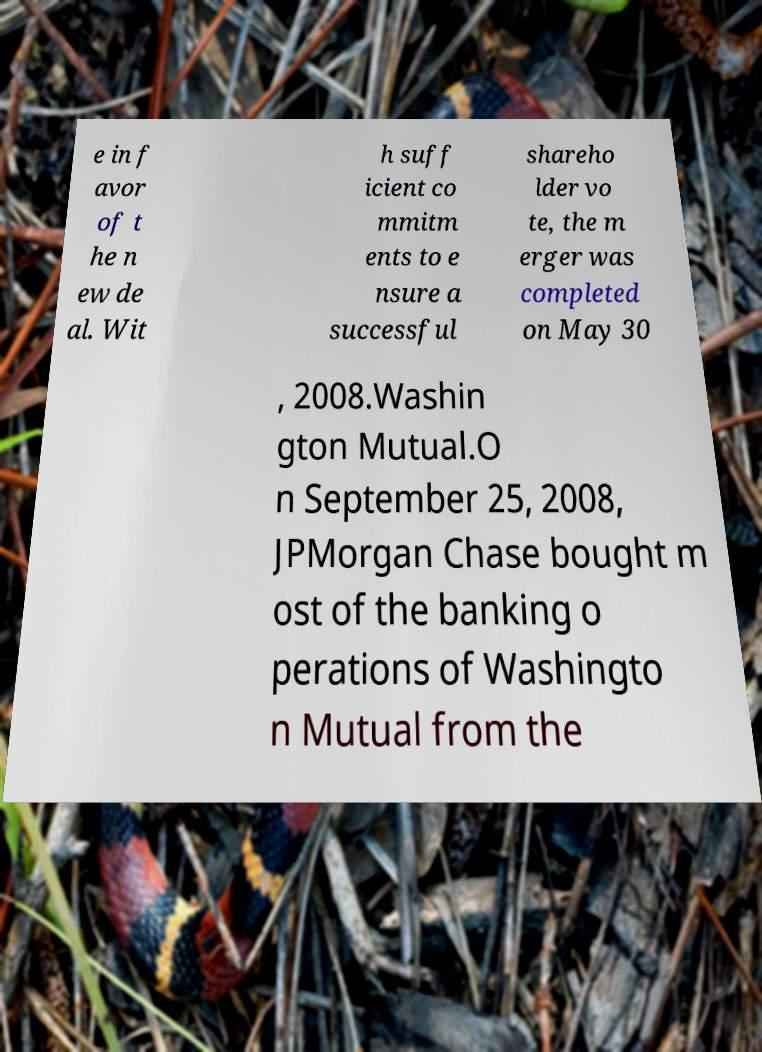Please read and relay the text visible in this image. What does it say? e in f avor of t he n ew de al. Wit h suff icient co mmitm ents to e nsure a successful shareho lder vo te, the m erger was completed on May 30 , 2008.Washin gton Mutual.O n September 25, 2008, JPMorgan Chase bought m ost of the banking o perations of Washingto n Mutual from the 